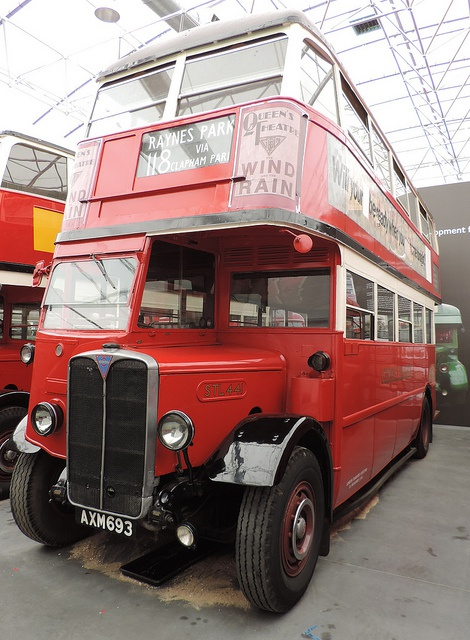Describe the objects in this image and their specific colors. I can see bus in white, black, lightgray, brown, and darkgray tones and bus in white, black, brown, lightgray, and maroon tones in this image. 